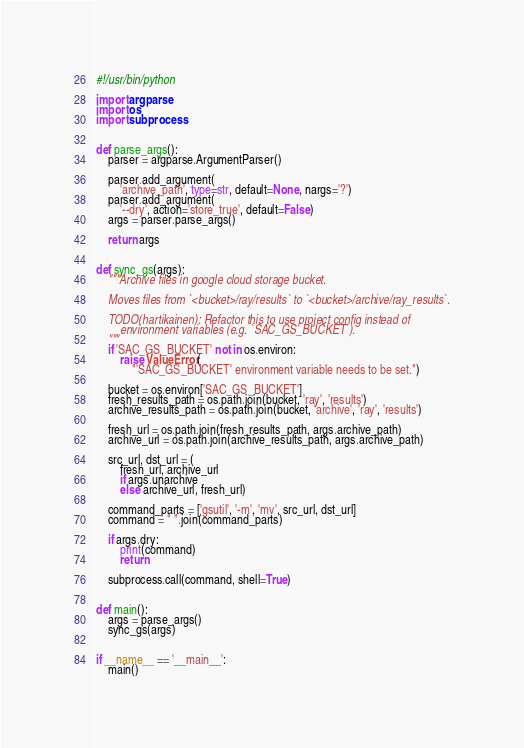Convert code to text. <code><loc_0><loc_0><loc_500><loc_500><_Python_>#!/usr/bin/python

import argparse
import os
import subprocess


def parse_args():
    parser = argparse.ArgumentParser()

    parser.add_argument(
        'archive_path', type=str, default=None, nargs='?')
    parser.add_argument(
        '--dry', action='store_true', default=False)
    args = parser.parse_args()

    return args


def sync_gs(args):
    """Archive files in google cloud storage bucket.

    Moves files from `<bucket>/ray/results` to `<bucket>/archive/ray_results`.

    TODO(hartikainen): Refactor this to use project config instead of
        environment variables (e.g. `SAC_GS_BUCKET`).
    """
    if 'SAC_GS_BUCKET' not in os.environ:
        raise ValueError(
            "'SAC_GS_BUCKET' environment variable needs to be set.")

    bucket = os.environ['SAC_GS_BUCKET']
    fresh_results_path = os.path.join(bucket, 'ray', 'results')
    archive_results_path = os.path.join(bucket, 'archive', 'ray', 'results')

    fresh_url = os.path.join(fresh_results_path, args.archive_path)
    archive_url = os.path.join(archive_results_path, args.archive_path)

    src_url, dst_url = (
        fresh_url, archive_url
        if args.unarchive
        else archive_url, fresh_url)

    command_parts = ['gsutil', '-m', 'mv', src_url, dst_url]
    command = " ".join(command_parts)

    if args.dry:
        print(command)
        return

    subprocess.call(command, shell=True)


def main():
    args = parse_args()
    sync_gs(args)


if __name__ == '__main__':
    main()
</code> 